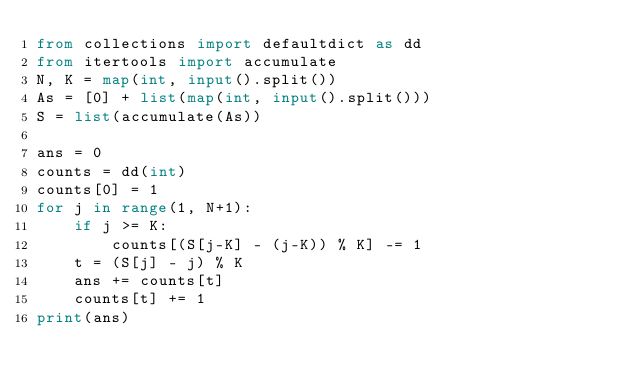Convert code to text. <code><loc_0><loc_0><loc_500><loc_500><_Python_>from collections import defaultdict as dd
from itertools import accumulate
N, K = map(int, input().split())
As = [0] + list(map(int, input().split()))
S = list(accumulate(As))

ans = 0
counts = dd(int)
counts[0] = 1
for j in range(1, N+1):
    if j >= K:
        counts[(S[j-K] - (j-K)) % K] -= 1
    t = (S[j] - j) % K
    ans += counts[t]
    counts[t] += 1
print(ans)</code> 